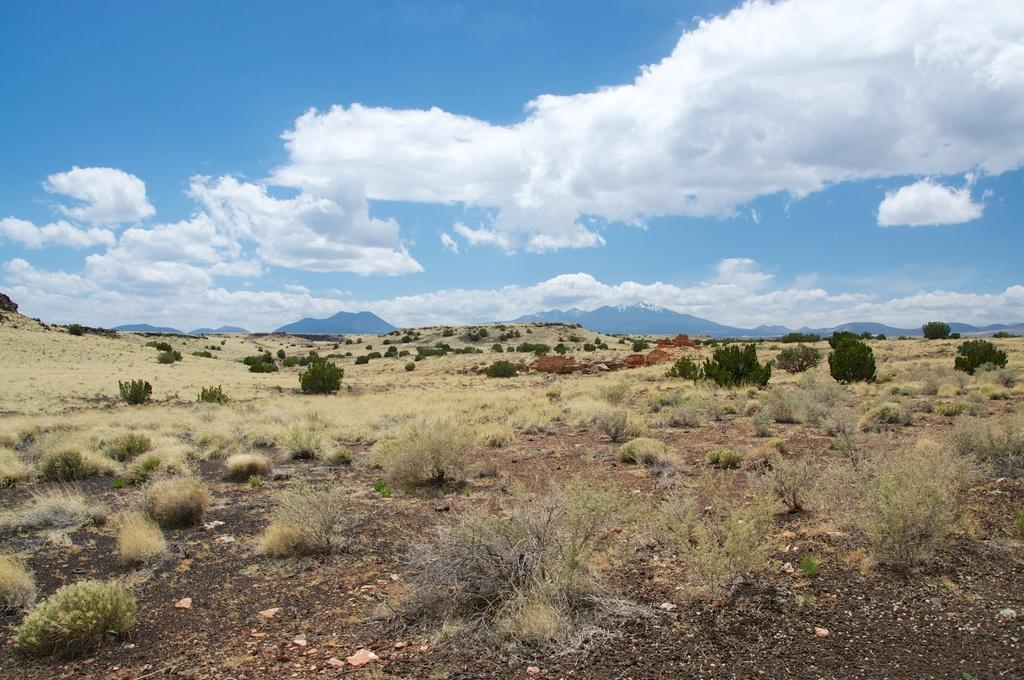What type of terrain is visible in the image? There is an open grass ground in the image. What can be found on the grass ground? There are multiple plants on the grass ground. What is visible in the distance in the image? Mountains and clouds are visible in the background of the image. What part of the natural environment is visible in the image? The sky is visible in the background of the image. Can you suggest a way to fix the crack in the kitty's paw in the image? There is no kitty or crack present in the image. 